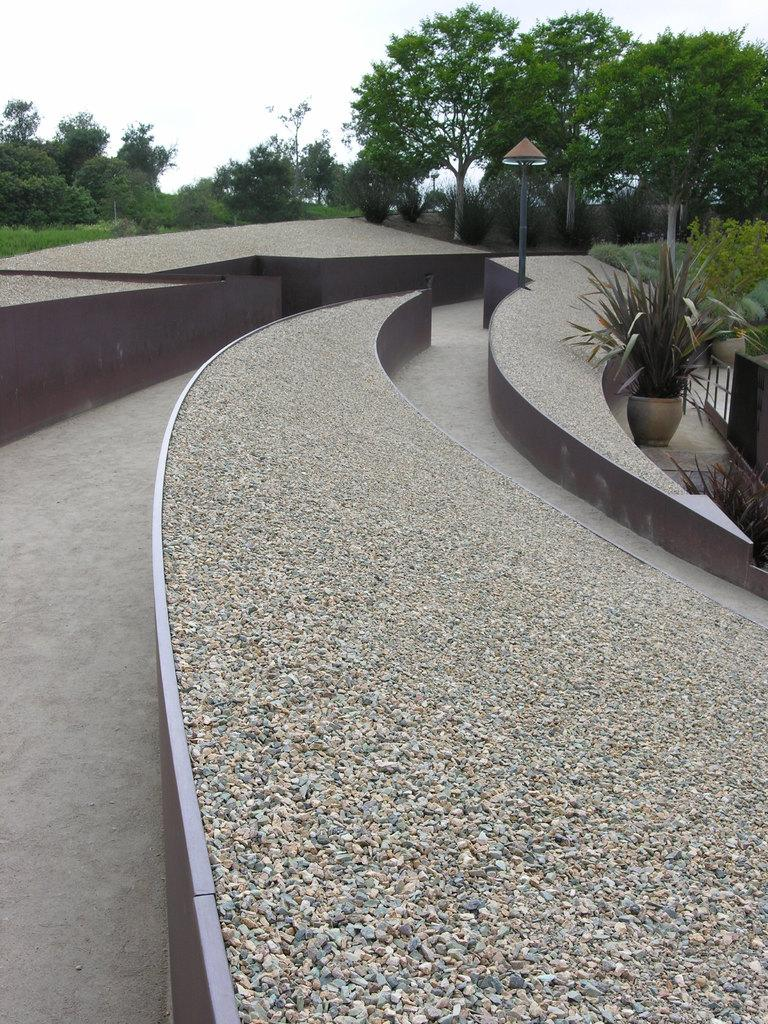What type of vegetation is present in the image? There are plants and trees in the image. What is the color of the plants and trees in the image? The plants and trees are green in color. What structure can be seen in the image, attached to a pole? There is a board attached to a pole in the image. What can be seen in the background of the image? The sky is visible in the background of the image. What is the color of the sky in the image? The color of the sky in the image is white. Can you see a collar on any of the plants or trees in the image? No, there are no collars present on the plants or trees in the image. Is there a knife being used to cut the plants or trees in the image? No, there is no knife visible in the image, and the plants and trees are not being cut. 